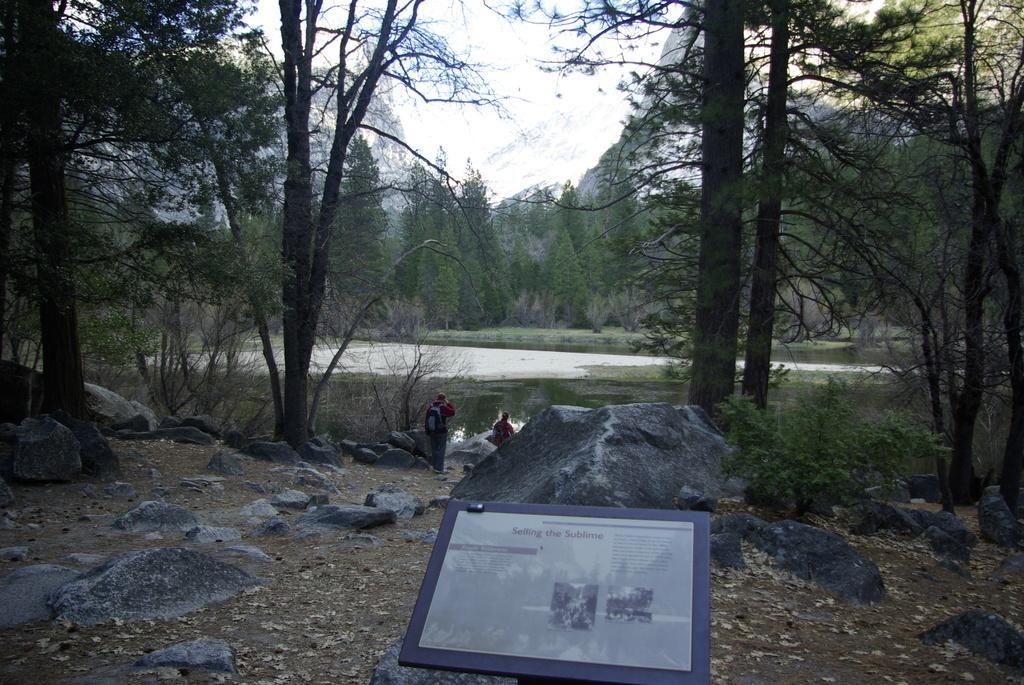In one or two sentences, can you explain what this image depicts? At the bottom of this image, there is a board arranged on a hill, on which there are trees and stones. In the background, there are two persons, there is water, there are trees, a mountain and there is sky. 